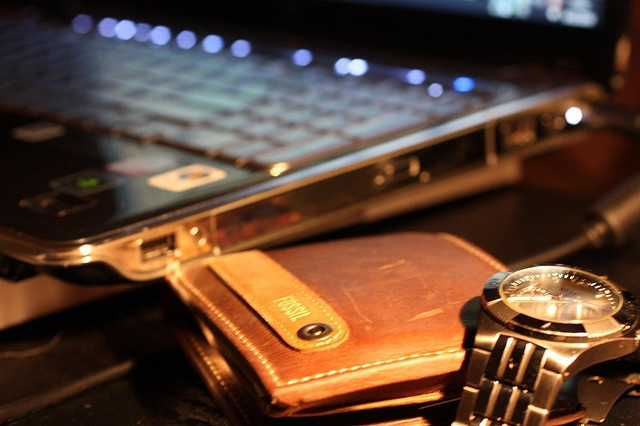Describe the objects in this image and their specific colors. I can see laptop in black, gray, and darkgray tones and clock in black, tan, and brown tones in this image. 